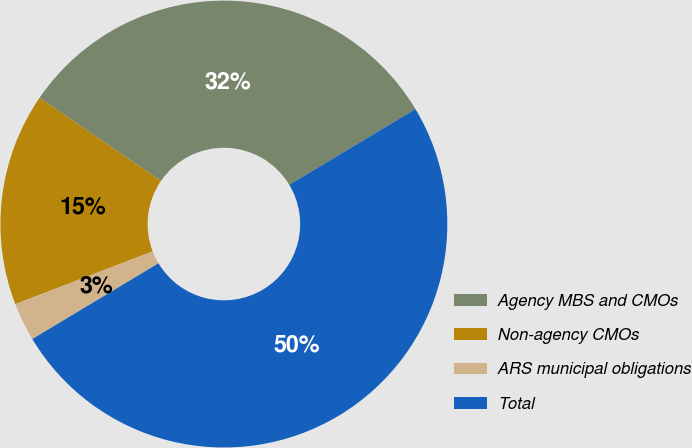Convert chart to OTSL. <chart><loc_0><loc_0><loc_500><loc_500><pie_chart><fcel>Agency MBS and CMOs<fcel>Non-agency CMOs<fcel>ARS municipal obligations<fcel>Total<nl><fcel>31.84%<fcel>15.39%<fcel>2.77%<fcel>50.0%<nl></chart> 